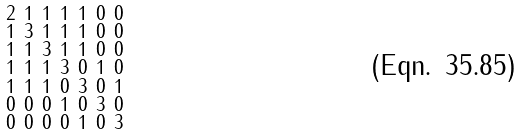<formula> <loc_0><loc_0><loc_500><loc_500>\begin{smallmatrix} 2 & 1 & 1 & 1 & 1 & 0 & 0 \\ 1 & 3 & 1 & 1 & 1 & 0 & 0 \\ 1 & 1 & 3 & 1 & 1 & 0 & 0 \\ 1 & 1 & 1 & 3 & 0 & 1 & 0 \\ 1 & 1 & 1 & 0 & 3 & 0 & 1 \\ 0 & 0 & 0 & 1 & 0 & 3 & 0 \\ 0 & 0 & 0 & 0 & 1 & 0 & 3 \end{smallmatrix}</formula> 